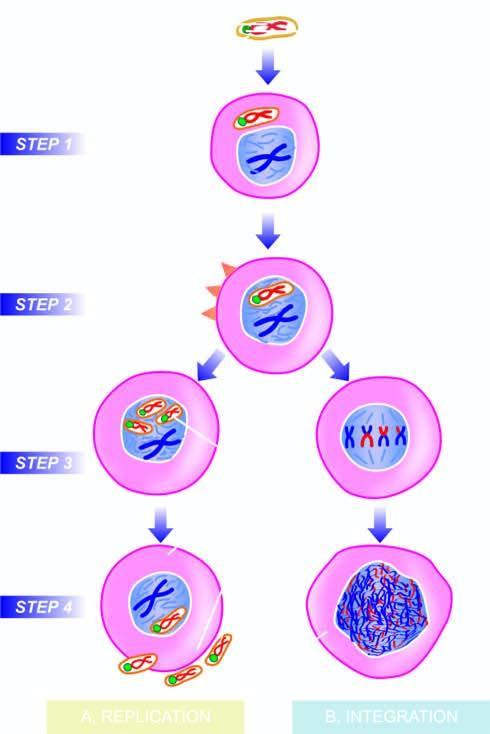re the new virions released, accompanied by host cell lysis?
Answer the question using a single word or phrase. Yes 